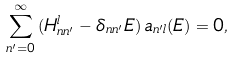Convert formula to latex. <formula><loc_0><loc_0><loc_500><loc_500>\sum _ { n ^ { \prime } = 0 } ^ { \infty } \, ( H _ { n n ^ { \prime } } ^ { l } - \delta _ { n n ^ { \prime } } E ) \, a _ { n ^ { \prime } l } ( E ) = 0 ,</formula> 